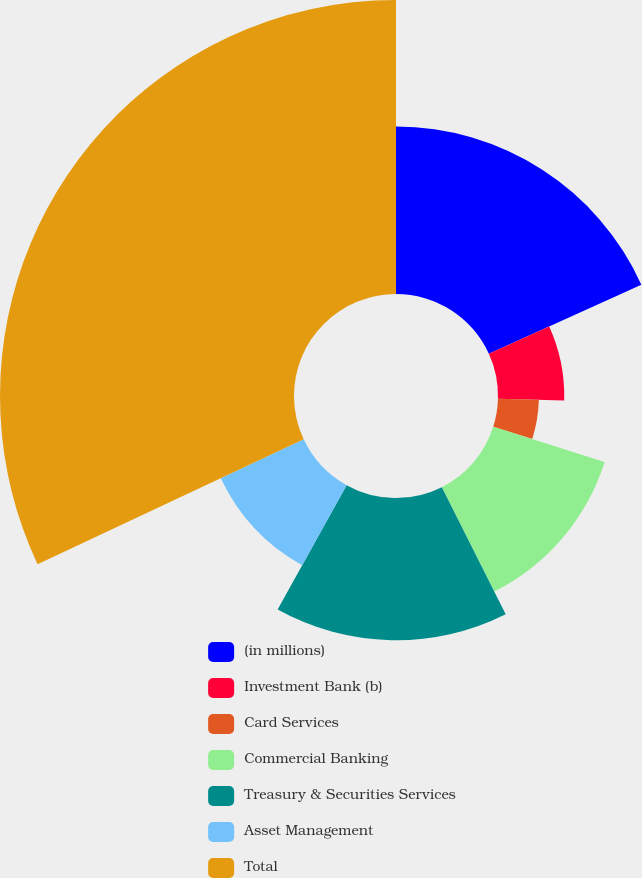Convert chart to OTSL. <chart><loc_0><loc_0><loc_500><loc_500><pie_chart><fcel>(in millions)<fcel>Investment Bank (b)<fcel>Card Services<fcel>Commercial Banking<fcel>Treasury & Securities Services<fcel>Asset Management<fcel>Total<nl><fcel>18.22%<fcel>7.21%<fcel>4.45%<fcel>12.71%<fcel>15.47%<fcel>9.96%<fcel>31.99%<nl></chart> 